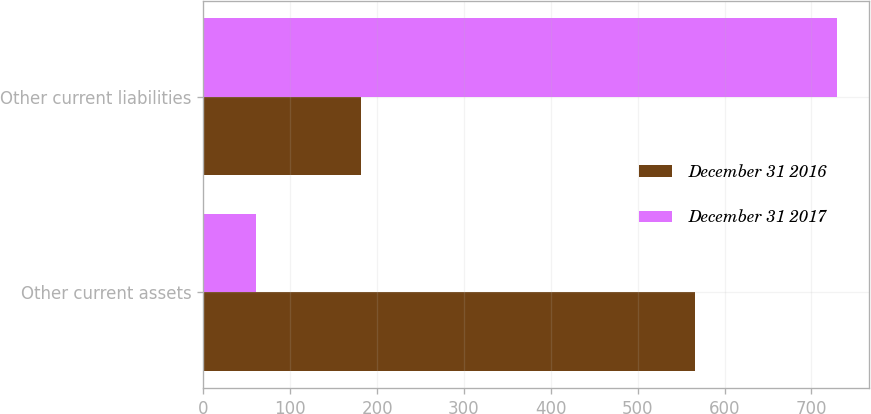Convert chart to OTSL. <chart><loc_0><loc_0><loc_500><loc_500><stacked_bar_chart><ecel><fcel>Other current assets<fcel>Other current liabilities<nl><fcel>December 31 2016<fcel>566<fcel>182<nl><fcel>December 31 2017<fcel>60<fcel>730<nl></chart> 